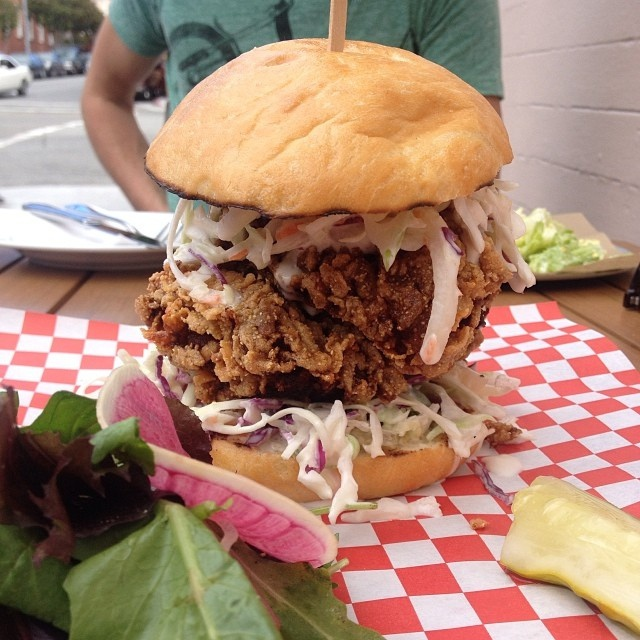Describe the objects in this image and their specific colors. I can see sandwich in gray, tan, maroon, and brown tones, dining table in gray, lightgray, salmon, lightpink, and khaki tones, people in gray and teal tones, dining table in gray, maroon, black, and salmon tones, and car in gray, lightgray, and darkgray tones in this image. 